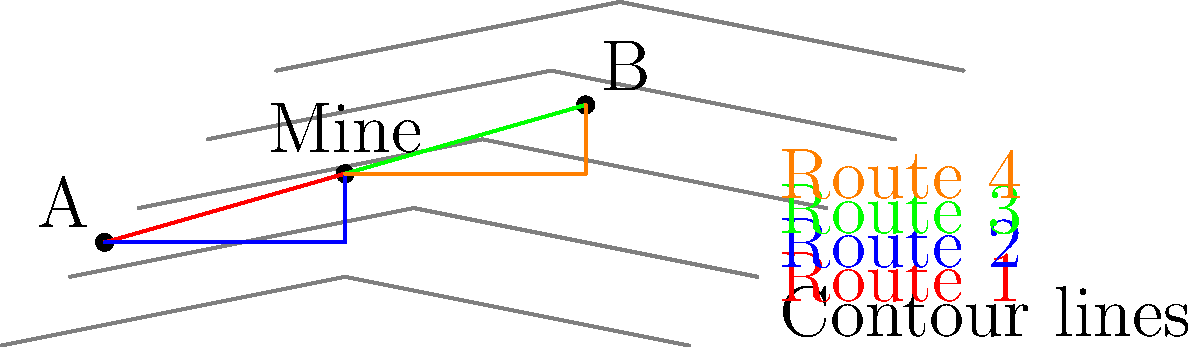Based on the topographical map showing two villages (A and B) and the Lueshe mine, which route would be the safest for villagers from point A to reach the mine during the rainy season? To determine the safest route from village A to the mine during the rainy season, we need to analyze the topography and consider the following steps:

1. Interpret the contour lines:
   - Closer lines indicate steeper terrain
   - Wider spacing indicates flatter terrain

2. Identify the routes:
   - Route 1 (red): Direct path from A to the mine
   - Route 2 (blue): Path following contour lines from A to the mine

3. Analyze the routes:
   - Route 1 crosses contour lines perpendicularly, indicating a steep climb
   - Route 2 follows contour lines more closely, suggesting a gentler slope

4. Consider rainy season implications:
   - Steeper routes are more prone to erosion and landslides during heavy rains
   - Gentler slopes provide better stability and less risk of flooding

5. Compare the safety of each route:
   - Route 1 is more direct but riskier due to its steepness
   - Route 2 is longer but safer as it avoids steep climbs

6. Conclude based on safety:
   - Route 2 (blue) is the safest option during the rainy season as it minimizes the risk of landslides and provides a more stable path
Answer: Route 2 (blue path) 